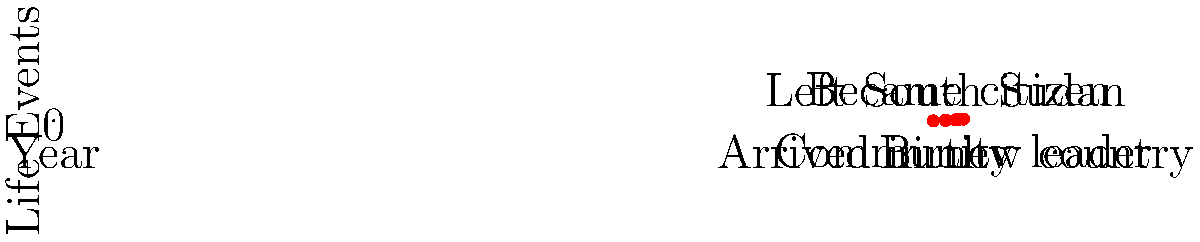The graph represents significant life events of a South Sudanese immigrant. If we consider the y-axis as representing the impact of each event (0 being least impactful, 4 being most impactful), what is the total sum of the impact values for all events that occurred after the year 2000? To solve this problem, we need to follow these steps:

1. Identify the events that occurred after the year 2000:
   - Arrived in new country (2005)
   - Became citizen (2011)
   - Community leader (2023)

2. Determine the impact value (y-coordinate) for each of these events:
   - Arrived in new country: $y = 2$
   - Became citizen: $y = 3$
   - Community leader: $y = 4$

3. Sum up the impact values:
   $2 + 3 + 4 = 9$

Therefore, the total sum of the impact values for all events that occurred after the year 2000 is 9.
Answer: 9 